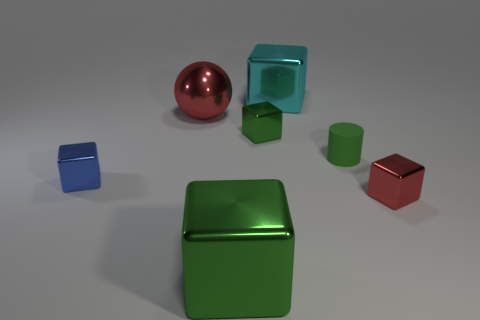Subtract all green cylinders. How many green blocks are left? 2 Add 2 yellow matte cubes. How many objects exist? 9 Subtract all small metallic blocks. How many blocks are left? 2 Subtract 1 blocks. How many blocks are left? 4 Subtract all green blocks. How many blocks are left? 3 Subtract all cylinders. How many objects are left? 6 Add 2 green metallic things. How many green metallic things are left? 4 Add 7 red balls. How many red balls exist? 8 Subtract 1 red balls. How many objects are left? 6 Subtract all gray blocks. Subtract all brown cylinders. How many blocks are left? 5 